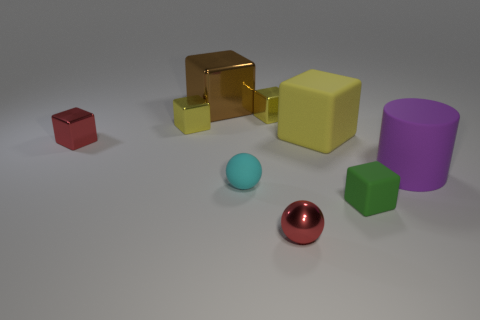Add 1 small yellow spheres. How many objects exist? 10 Subtract 0 blue cubes. How many objects are left? 9 Subtract all cylinders. How many objects are left? 8 Subtract 2 spheres. How many spheres are left? 0 Subtract all purple spheres. Subtract all yellow cylinders. How many spheres are left? 2 Subtract all gray spheres. How many red cylinders are left? 0 Subtract all tiny red balls. Subtract all cyan matte objects. How many objects are left? 7 Add 9 red balls. How many red balls are left? 10 Add 4 large gray metal things. How many large gray metal things exist? 4 Subtract all cyan balls. How many balls are left? 1 